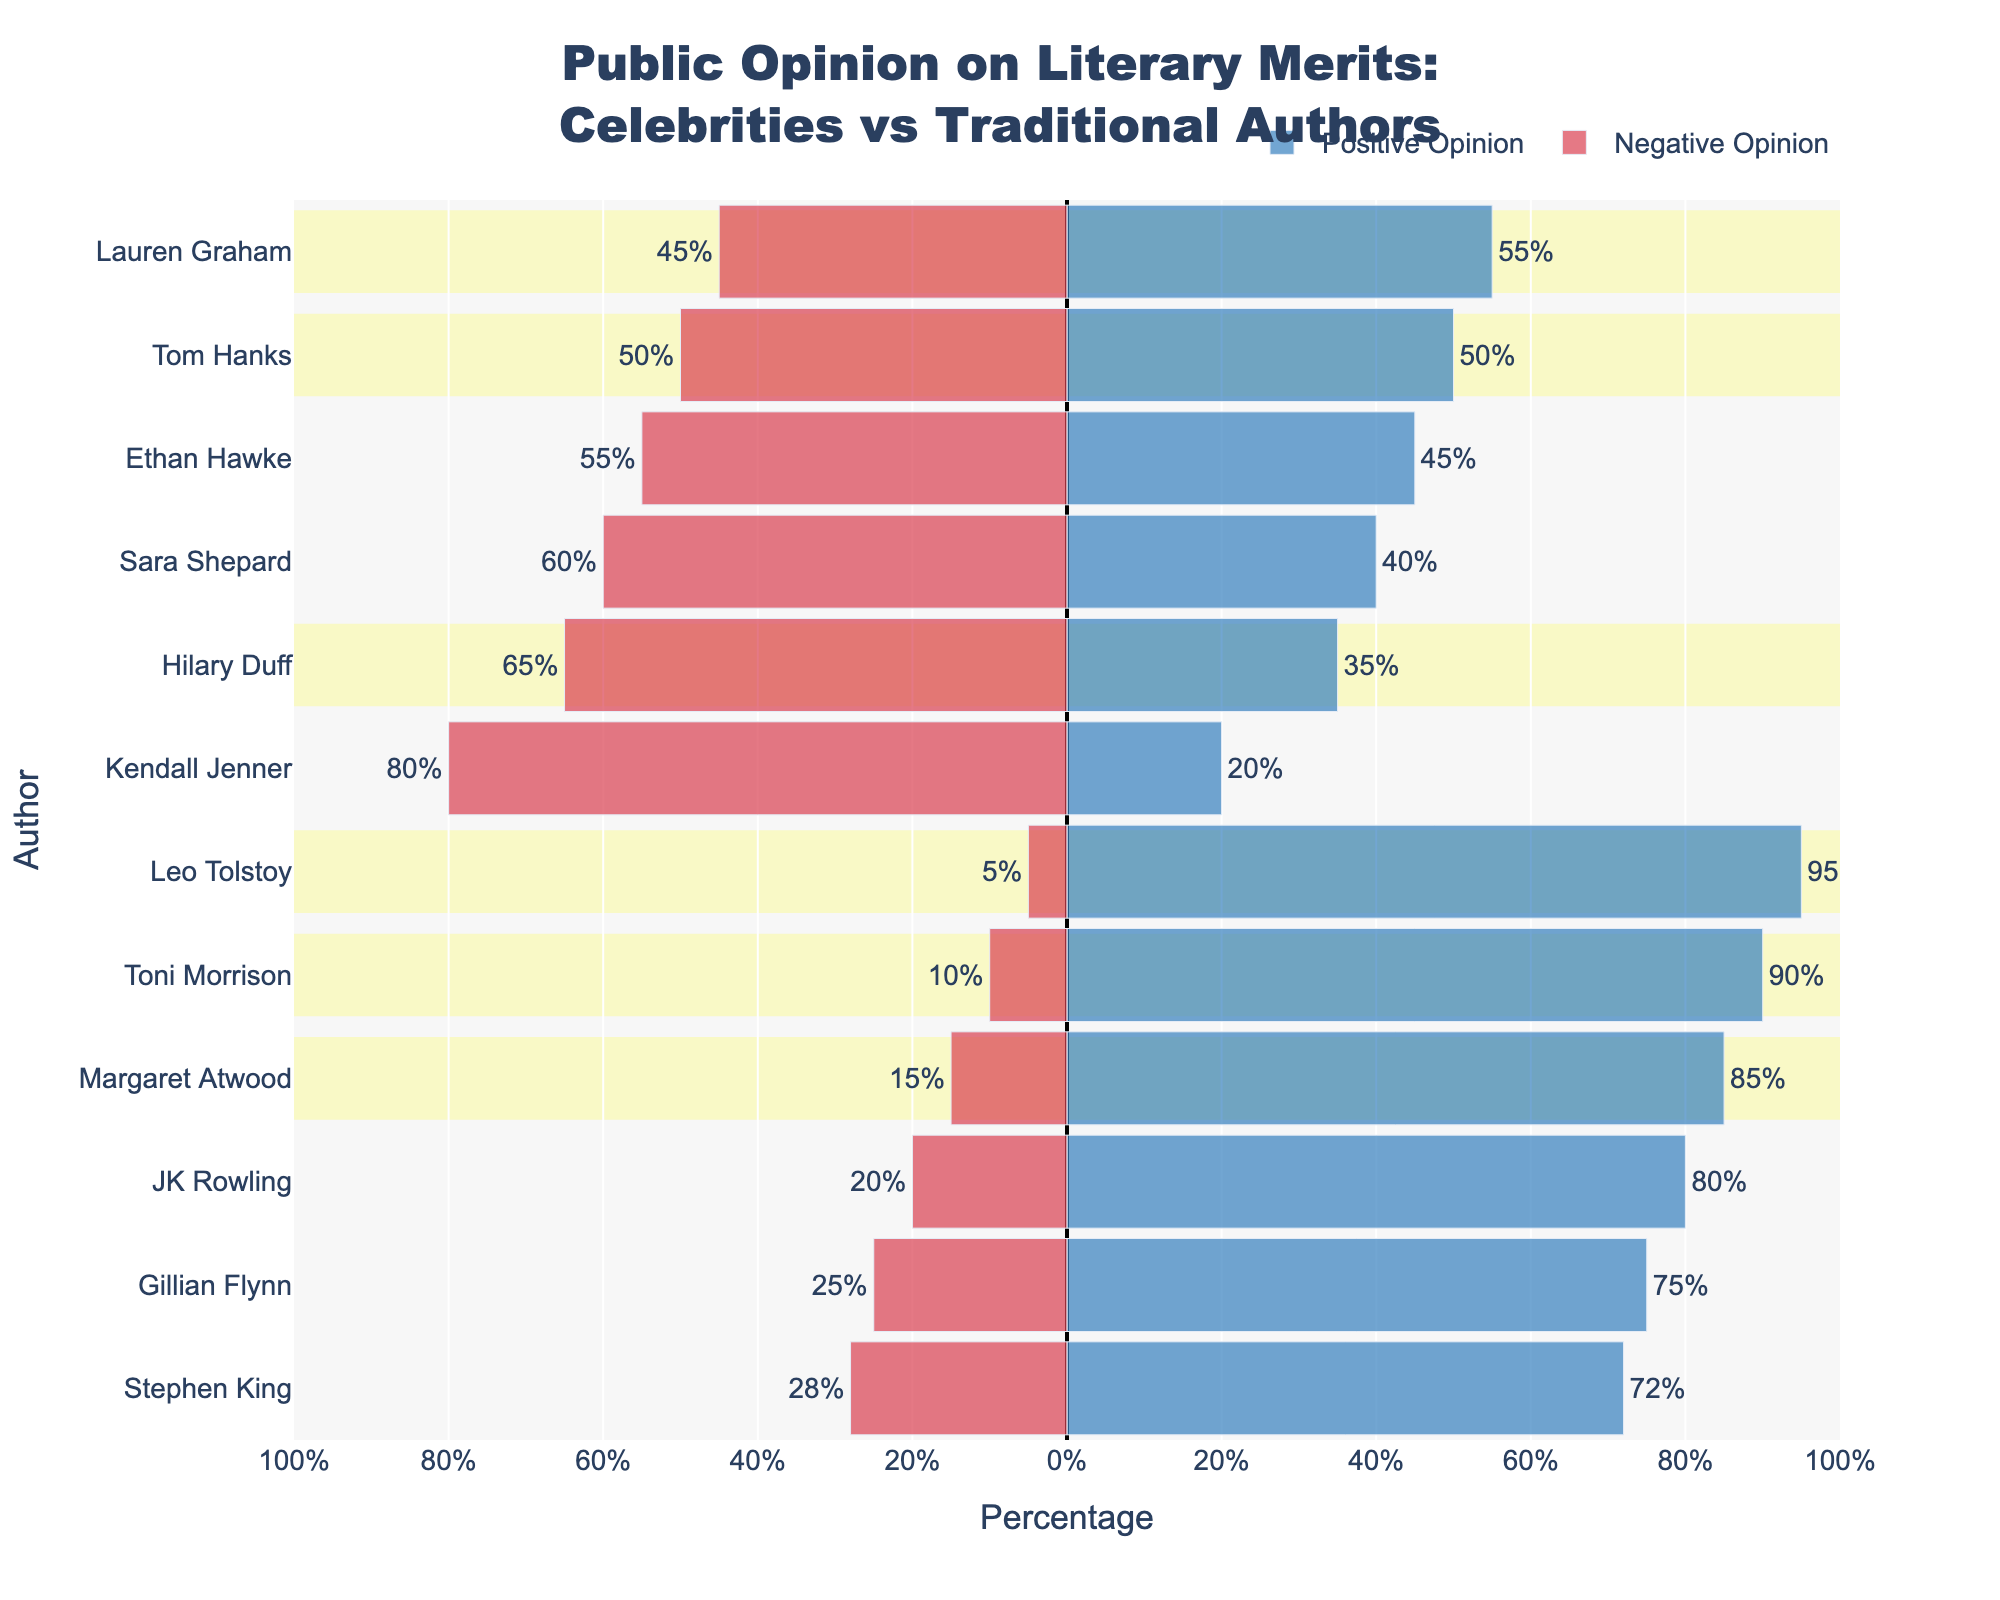How do public opinions differ between Stephen King and Sara Shepard? The figure shows that Stephen King, a traditional author, has 72% positive and 28% negative opinions. Sara Shepard, a celebrity author, has 40% positive and 60% negative opinions. The difference in positive opinions is 72% - 40% = 32% more for Stephen King, and the difference in negative opinions is 60% - 28% = 32% more against Sara Shepard.
Answer: Stephen King is perceived 32% more positively and Sara Shepard 32% more negatively What is the sum of positive opinions for traditional authors? The positive opinions for traditional authors are: Stephen King (72%), Margaret Atwood (85%), JK Rowling (80%), Toni Morrison (90%), Leo Tolstoy (95%), Gillian Flynn (75%). Summing these values: 72% + 85% + 80% + 90% + 95% + 75% = 497%.
Answer: 497% Which celebrity author has the highest positive opinion? The figure shows the positive opinions for celebrity authors as: Sara Shepard (40%), Ethan Hawke (45%), Tom Hanks (50%), Lauren Graham (55%), Kendall Jenner (20%), Hilary Duff (35%). Among these, Lauren Graham has the highest positive opinion with 55%.
Answer: Lauren Graham What is the average negative opinion for celebrity authors? The negative opinions for celebrity authors are: Sara Shepard (60%), Ethan Hawke (55%), Tom Hanks (50%), Lauren Graham (45%), Kendall Jenner (80%), Hilary Duff (65%). The sum is 60% + 55% + 50% + 45% + 80% + 65% = 355%. There are 6 celebrity authors, so the average negative opinion is 355 / 6 ≈ 59.17%.
Answer: 59.17% How does Tom Hanks’ public opinion compare to Toni Morrison’s? Tom Hanks, a celebrity author, has a 50% positive and a 50% negative opinion, while Toni Morrison, a traditional author, has a 90% positive and 10% negative opinion. Toni Morrison has 40% more positive and 40% less negative opinions compared to Tom Hanks.
Answer: Toni Morrison is perceived 40% more positively and 40% less negatively What is the ratio of positive to negative opinions for Lauren Graham? Lauren Graham has 55% positive and 45% negative opinions. The ratio of positive to negative opinions is 55 / 45 = 1.22.
Answer: 1.22 Which author has the highest negative opinion and what is the value? The figure indicates that Kendall Jenner, a celebrity author, has the highest negative opinion at 80%.
Answer: Kendall Jenner, 80% What is the overall median positive opinion of all authors? Listing the positive opinions in ascending order: 20%, 35%, 40%, 45%, 50%, 55%, 72%, 75%, 80%, 85%, 90%, 95%. The median is the average of the 6th and 7th values: (55% + 72%) / 2 = 63.5%.
Answer: 63.5% 